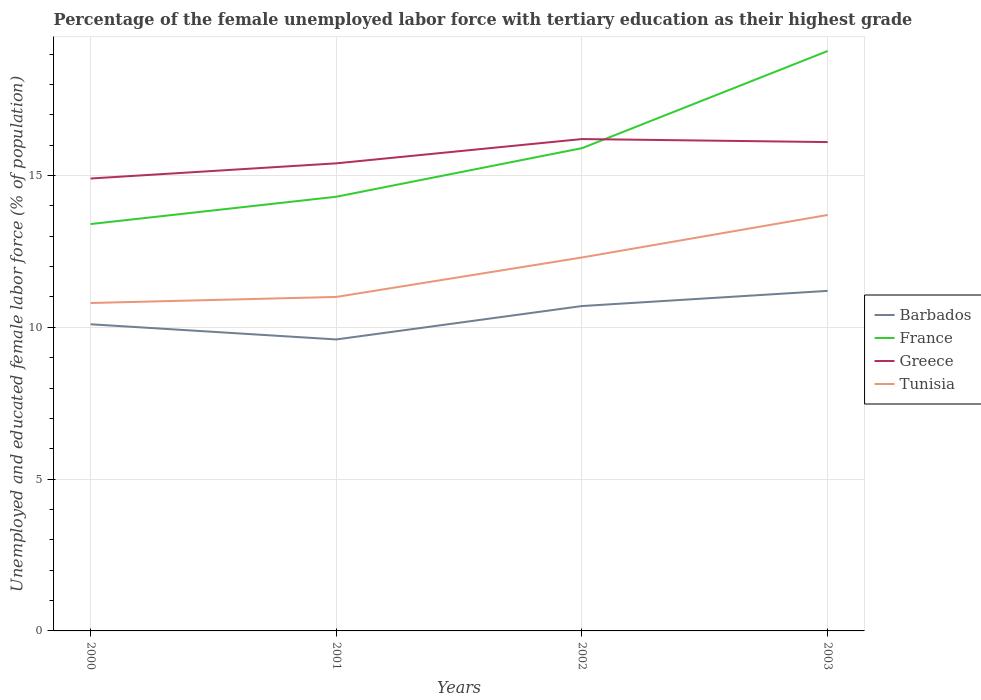Is the number of lines equal to the number of legend labels?
Keep it short and to the point. Yes. Across all years, what is the maximum percentage of the unemployed female labor force with tertiary education in Greece?
Ensure brevity in your answer.  14.9. What is the total percentage of the unemployed female labor force with tertiary education in Tunisia in the graph?
Your answer should be very brief. -1.5. What is the difference between the highest and the second highest percentage of the unemployed female labor force with tertiary education in Greece?
Ensure brevity in your answer.  1.3. What is the difference between the highest and the lowest percentage of the unemployed female labor force with tertiary education in Greece?
Offer a very short reply. 2. How many years are there in the graph?
Your answer should be compact. 4. What is the difference between two consecutive major ticks on the Y-axis?
Provide a short and direct response. 5. Does the graph contain any zero values?
Keep it short and to the point. No. Does the graph contain grids?
Provide a succinct answer. Yes. Where does the legend appear in the graph?
Provide a succinct answer. Center right. How many legend labels are there?
Offer a terse response. 4. How are the legend labels stacked?
Your answer should be very brief. Vertical. What is the title of the graph?
Ensure brevity in your answer.  Percentage of the female unemployed labor force with tertiary education as their highest grade. What is the label or title of the Y-axis?
Give a very brief answer. Unemployed and educated female labor force (% of population). What is the Unemployed and educated female labor force (% of population) of Barbados in 2000?
Keep it short and to the point. 10.1. What is the Unemployed and educated female labor force (% of population) in France in 2000?
Offer a very short reply. 13.4. What is the Unemployed and educated female labor force (% of population) in Greece in 2000?
Your answer should be very brief. 14.9. What is the Unemployed and educated female labor force (% of population) of Tunisia in 2000?
Keep it short and to the point. 10.8. What is the Unemployed and educated female labor force (% of population) in Barbados in 2001?
Offer a very short reply. 9.6. What is the Unemployed and educated female labor force (% of population) of France in 2001?
Make the answer very short. 14.3. What is the Unemployed and educated female labor force (% of population) in Greece in 2001?
Keep it short and to the point. 15.4. What is the Unemployed and educated female labor force (% of population) in Tunisia in 2001?
Keep it short and to the point. 11. What is the Unemployed and educated female labor force (% of population) of Barbados in 2002?
Offer a terse response. 10.7. What is the Unemployed and educated female labor force (% of population) of France in 2002?
Ensure brevity in your answer.  15.9. What is the Unemployed and educated female labor force (% of population) of Greece in 2002?
Ensure brevity in your answer.  16.2. What is the Unemployed and educated female labor force (% of population) in Tunisia in 2002?
Provide a succinct answer. 12.3. What is the Unemployed and educated female labor force (% of population) of Barbados in 2003?
Make the answer very short. 11.2. What is the Unemployed and educated female labor force (% of population) of France in 2003?
Give a very brief answer. 19.1. What is the Unemployed and educated female labor force (% of population) of Greece in 2003?
Provide a succinct answer. 16.1. What is the Unemployed and educated female labor force (% of population) in Tunisia in 2003?
Your response must be concise. 13.7. Across all years, what is the maximum Unemployed and educated female labor force (% of population) in Barbados?
Ensure brevity in your answer.  11.2. Across all years, what is the maximum Unemployed and educated female labor force (% of population) of France?
Your answer should be compact. 19.1. Across all years, what is the maximum Unemployed and educated female labor force (% of population) in Greece?
Your response must be concise. 16.2. Across all years, what is the maximum Unemployed and educated female labor force (% of population) in Tunisia?
Your answer should be very brief. 13.7. Across all years, what is the minimum Unemployed and educated female labor force (% of population) of Barbados?
Your answer should be very brief. 9.6. Across all years, what is the minimum Unemployed and educated female labor force (% of population) in France?
Your response must be concise. 13.4. Across all years, what is the minimum Unemployed and educated female labor force (% of population) of Greece?
Give a very brief answer. 14.9. Across all years, what is the minimum Unemployed and educated female labor force (% of population) of Tunisia?
Your answer should be very brief. 10.8. What is the total Unemployed and educated female labor force (% of population) of Barbados in the graph?
Make the answer very short. 41.6. What is the total Unemployed and educated female labor force (% of population) in France in the graph?
Offer a terse response. 62.7. What is the total Unemployed and educated female labor force (% of population) in Greece in the graph?
Keep it short and to the point. 62.6. What is the total Unemployed and educated female labor force (% of population) in Tunisia in the graph?
Offer a terse response. 47.8. What is the difference between the Unemployed and educated female labor force (% of population) in Barbados in 2000 and that in 2001?
Provide a succinct answer. 0.5. What is the difference between the Unemployed and educated female labor force (% of population) in Greece in 2000 and that in 2001?
Make the answer very short. -0.5. What is the difference between the Unemployed and educated female labor force (% of population) of Barbados in 2000 and that in 2002?
Make the answer very short. -0.6. What is the difference between the Unemployed and educated female labor force (% of population) of France in 2000 and that in 2002?
Provide a succinct answer. -2.5. What is the difference between the Unemployed and educated female labor force (% of population) of Greece in 2000 and that in 2002?
Offer a very short reply. -1.3. What is the difference between the Unemployed and educated female labor force (% of population) in Tunisia in 2000 and that in 2002?
Offer a very short reply. -1.5. What is the difference between the Unemployed and educated female labor force (% of population) of Greece in 2000 and that in 2003?
Make the answer very short. -1.2. What is the difference between the Unemployed and educated female labor force (% of population) in Tunisia in 2001 and that in 2002?
Keep it short and to the point. -1.3. What is the difference between the Unemployed and educated female labor force (% of population) in Greece in 2001 and that in 2003?
Provide a short and direct response. -0.7. What is the difference between the Unemployed and educated female labor force (% of population) in Tunisia in 2001 and that in 2003?
Make the answer very short. -2.7. What is the difference between the Unemployed and educated female labor force (% of population) of Barbados in 2002 and that in 2003?
Make the answer very short. -0.5. What is the difference between the Unemployed and educated female labor force (% of population) in France in 2002 and that in 2003?
Offer a very short reply. -3.2. What is the difference between the Unemployed and educated female labor force (% of population) in Tunisia in 2002 and that in 2003?
Your answer should be very brief. -1.4. What is the difference between the Unemployed and educated female labor force (% of population) of Barbados in 2000 and the Unemployed and educated female labor force (% of population) of France in 2001?
Offer a terse response. -4.2. What is the difference between the Unemployed and educated female labor force (% of population) of France in 2000 and the Unemployed and educated female labor force (% of population) of Greece in 2001?
Your answer should be very brief. -2. What is the difference between the Unemployed and educated female labor force (% of population) of France in 2000 and the Unemployed and educated female labor force (% of population) of Tunisia in 2001?
Your answer should be very brief. 2.4. What is the difference between the Unemployed and educated female labor force (% of population) in Greece in 2000 and the Unemployed and educated female labor force (% of population) in Tunisia in 2001?
Keep it short and to the point. 3.9. What is the difference between the Unemployed and educated female labor force (% of population) in Barbados in 2000 and the Unemployed and educated female labor force (% of population) in France in 2002?
Keep it short and to the point. -5.8. What is the difference between the Unemployed and educated female labor force (% of population) of Barbados in 2000 and the Unemployed and educated female labor force (% of population) of Greece in 2002?
Offer a very short reply. -6.1. What is the difference between the Unemployed and educated female labor force (% of population) of France in 2000 and the Unemployed and educated female labor force (% of population) of Tunisia in 2002?
Your answer should be compact. 1.1. What is the difference between the Unemployed and educated female labor force (% of population) in Greece in 2000 and the Unemployed and educated female labor force (% of population) in Tunisia in 2002?
Make the answer very short. 2.6. What is the difference between the Unemployed and educated female labor force (% of population) in Barbados in 2000 and the Unemployed and educated female labor force (% of population) in Tunisia in 2003?
Provide a succinct answer. -3.6. What is the difference between the Unemployed and educated female labor force (% of population) in Barbados in 2001 and the Unemployed and educated female labor force (% of population) in France in 2002?
Make the answer very short. -6.3. What is the difference between the Unemployed and educated female labor force (% of population) in Barbados in 2001 and the Unemployed and educated female labor force (% of population) in Tunisia in 2002?
Ensure brevity in your answer.  -2.7. What is the difference between the Unemployed and educated female labor force (% of population) of France in 2001 and the Unemployed and educated female labor force (% of population) of Greece in 2002?
Provide a short and direct response. -1.9. What is the difference between the Unemployed and educated female labor force (% of population) in Greece in 2001 and the Unemployed and educated female labor force (% of population) in Tunisia in 2002?
Give a very brief answer. 3.1. What is the difference between the Unemployed and educated female labor force (% of population) of Barbados in 2001 and the Unemployed and educated female labor force (% of population) of France in 2003?
Your answer should be very brief. -9.5. What is the difference between the Unemployed and educated female labor force (% of population) of Barbados in 2001 and the Unemployed and educated female labor force (% of population) of Greece in 2003?
Give a very brief answer. -6.5. What is the difference between the Unemployed and educated female labor force (% of population) in Barbados in 2001 and the Unemployed and educated female labor force (% of population) in Tunisia in 2003?
Keep it short and to the point. -4.1. What is the difference between the Unemployed and educated female labor force (% of population) in Barbados in 2002 and the Unemployed and educated female labor force (% of population) in Greece in 2003?
Keep it short and to the point. -5.4. What is the difference between the Unemployed and educated female labor force (% of population) in Barbados in 2002 and the Unemployed and educated female labor force (% of population) in Tunisia in 2003?
Provide a succinct answer. -3. What is the difference between the Unemployed and educated female labor force (% of population) of Greece in 2002 and the Unemployed and educated female labor force (% of population) of Tunisia in 2003?
Keep it short and to the point. 2.5. What is the average Unemployed and educated female labor force (% of population) of Barbados per year?
Provide a succinct answer. 10.4. What is the average Unemployed and educated female labor force (% of population) in France per year?
Offer a very short reply. 15.68. What is the average Unemployed and educated female labor force (% of population) of Greece per year?
Offer a terse response. 15.65. What is the average Unemployed and educated female labor force (% of population) of Tunisia per year?
Offer a terse response. 11.95. In the year 2000, what is the difference between the Unemployed and educated female labor force (% of population) in Barbados and Unemployed and educated female labor force (% of population) in France?
Your answer should be compact. -3.3. In the year 2000, what is the difference between the Unemployed and educated female labor force (% of population) of Barbados and Unemployed and educated female labor force (% of population) of Tunisia?
Keep it short and to the point. -0.7. In the year 2000, what is the difference between the Unemployed and educated female labor force (% of population) in France and Unemployed and educated female labor force (% of population) in Greece?
Give a very brief answer. -1.5. In the year 2000, what is the difference between the Unemployed and educated female labor force (% of population) of France and Unemployed and educated female labor force (% of population) of Tunisia?
Offer a terse response. 2.6. In the year 2001, what is the difference between the Unemployed and educated female labor force (% of population) of Barbados and Unemployed and educated female labor force (% of population) of Tunisia?
Your answer should be compact. -1.4. In the year 2001, what is the difference between the Unemployed and educated female labor force (% of population) of Greece and Unemployed and educated female labor force (% of population) of Tunisia?
Offer a very short reply. 4.4. In the year 2002, what is the difference between the Unemployed and educated female labor force (% of population) in Barbados and Unemployed and educated female labor force (% of population) in Tunisia?
Make the answer very short. -1.6. In the year 2003, what is the difference between the Unemployed and educated female labor force (% of population) of Barbados and Unemployed and educated female labor force (% of population) of Greece?
Provide a succinct answer. -4.9. In the year 2003, what is the difference between the Unemployed and educated female labor force (% of population) in France and Unemployed and educated female labor force (% of population) in Greece?
Provide a succinct answer. 3. In the year 2003, what is the difference between the Unemployed and educated female labor force (% of population) in France and Unemployed and educated female labor force (% of population) in Tunisia?
Give a very brief answer. 5.4. What is the ratio of the Unemployed and educated female labor force (% of population) in Barbados in 2000 to that in 2001?
Make the answer very short. 1.05. What is the ratio of the Unemployed and educated female labor force (% of population) of France in 2000 to that in 2001?
Keep it short and to the point. 0.94. What is the ratio of the Unemployed and educated female labor force (% of population) in Greece in 2000 to that in 2001?
Keep it short and to the point. 0.97. What is the ratio of the Unemployed and educated female labor force (% of population) of Tunisia in 2000 to that in 2001?
Provide a succinct answer. 0.98. What is the ratio of the Unemployed and educated female labor force (% of population) of Barbados in 2000 to that in 2002?
Provide a succinct answer. 0.94. What is the ratio of the Unemployed and educated female labor force (% of population) of France in 2000 to that in 2002?
Ensure brevity in your answer.  0.84. What is the ratio of the Unemployed and educated female labor force (% of population) of Greece in 2000 to that in 2002?
Ensure brevity in your answer.  0.92. What is the ratio of the Unemployed and educated female labor force (% of population) in Tunisia in 2000 to that in 2002?
Ensure brevity in your answer.  0.88. What is the ratio of the Unemployed and educated female labor force (% of population) of Barbados in 2000 to that in 2003?
Offer a very short reply. 0.9. What is the ratio of the Unemployed and educated female labor force (% of population) of France in 2000 to that in 2003?
Provide a succinct answer. 0.7. What is the ratio of the Unemployed and educated female labor force (% of population) of Greece in 2000 to that in 2003?
Make the answer very short. 0.93. What is the ratio of the Unemployed and educated female labor force (% of population) of Tunisia in 2000 to that in 2003?
Your answer should be compact. 0.79. What is the ratio of the Unemployed and educated female labor force (% of population) of Barbados in 2001 to that in 2002?
Give a very brief answer. 0.9. What is the ratio of the Unemployed and educated female labor force (% of population) of France in 2001 to that in 2002?
Ensure brevity in your answer.  0.9. What is the ratio of the Unemployed and educated female labor force (% of population) in Greece in 2001 to that in 2002?
Ensure brevity in your answer.  0.95. What is the ratio of the Unemployed and educated female labor force (% of population) in Tunisia in 2001 to that in 2002?
Your response must be concise. 0.89. What is the ratio of the Unemployed and educated female labor force (% of population) in Barbados in 2001 to that in 2003?
Ensure brevity in your answer.  0.86. What is the ratio of the Unemployed and educated female labor force (% of population) of France in 2001 to that in 2003?
Provide a succinct answer. 0.75. What is the ratio of the Unemployed and educated female labor force (% of population) in Greece in 2001 to that in 2003?
Your answer should be very brief. 0.96. What is the ratio of the Unemployed and educated female labor force (% of population) in Tunisia in 2001 to that in 2003?
Your answer should be very brief. 0.8. What is the ratio of the Unemployed and educated female labor force (% of population) in Barbados in 2002 to that in 2003?
Provide a short and direct response. 0.96. What is the ratio of the Unemployed and educated female labor force (% of population) of France in 2002 to that in 2003?
Your answer should be compact. 0.83. What is the ratio of the Unemployed and educated female labor force (% of population) of Tunisia in 2002 to that in 2003?
Offer a very short reply. 0.9. What is the difference between the highest and the second highest Unemployed and educated female labor force (% of population) in Barbados?
Offer a very short reply. 0.5. What is the difference between the highest and the lowest Unemployed and educated female labor force (% of population) of Barbados?
Your response must be concise. 1.6. What is the difference between the highest and the lowest Unemployed and educated female labor force (% of population) in France?
Your answer should be compact. 5.7. What is the difference between the highest and the lowest Unemployed and educated female labor force (% of population) in Tunisia?
Keep it short and to the point. 2.9. 